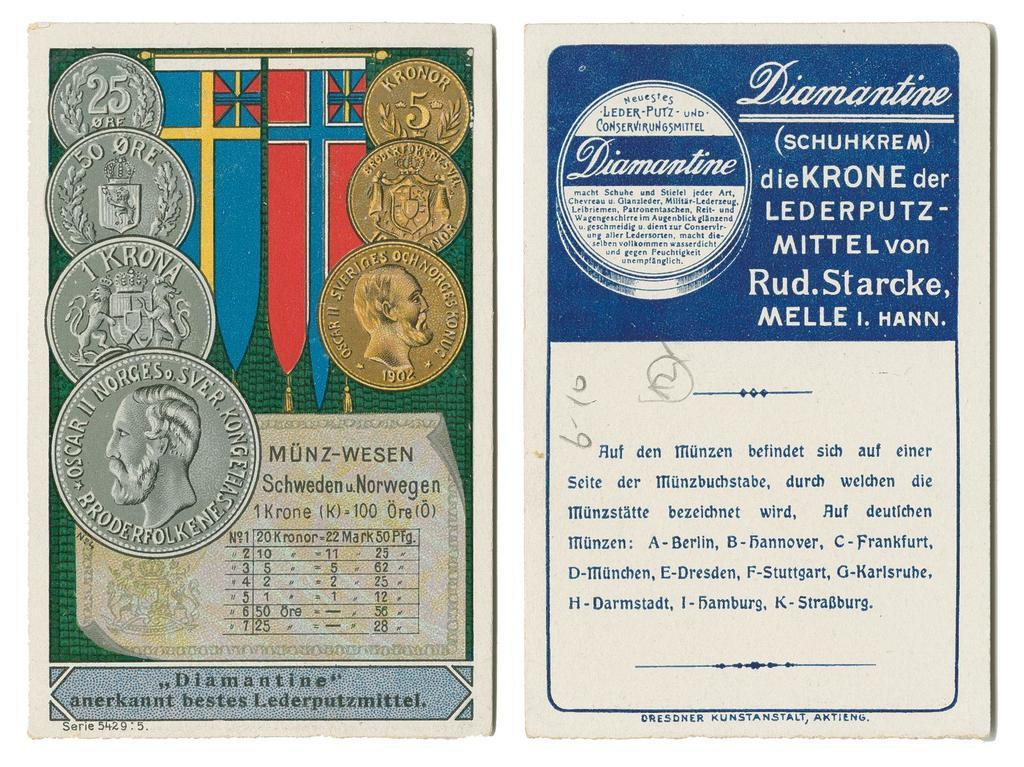Provide a one-sentence caption for the provided image. Two pages one with coins and medals and the other with a certificate in foreign writing. 